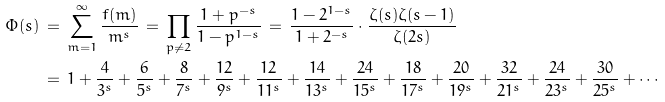<formula> <loc_0><loc_0><loc_500><loc_500>\varPhi ( s ) & \, = \, \sum _ { m = 1 } ^ { \infty } \frac { f ( m ) } { m ^ { s } } \, = \, \prod _ { p \neq 2 } \frac { 1 + p ^ { - s } } { 1 - p ^ { 1 - s } } \, = \, \frac { 1 - 2 ^ { 1 - s } } { 1 + 2 ^ { - s } } \cdot \frac { \zeta ( s ) \zeta ( s - 1 ) } { \zeta ( 2 s ) } \\ & \, = \, 1 + \frac { 4 } { 3 ^ { s } } + \frac { 6 } { 5 ^ { s } } + \frac { 8 } { 7 ^ { s } } + \frac { 1 2 } { 9 ^ { s } } + \frac { 1 2 } { 1 1 ^ { s } } + \frac { 1 4 } { 1 3 ^ { s } } + \frac { 2 4 } { 1 5 ^ { s } } + \frac { 1 8 } { 1 7 ^ { s } } + \frac { 2 0 } { 1 9 ^ { s } } + \frac { 3 2 } { 2 1 ^ { s } } + \frac { 2 4 } { 2 3 ^ { s } } + \frac { 3 0 } { 2 5 ^ { s } } + \cdots</formula> 